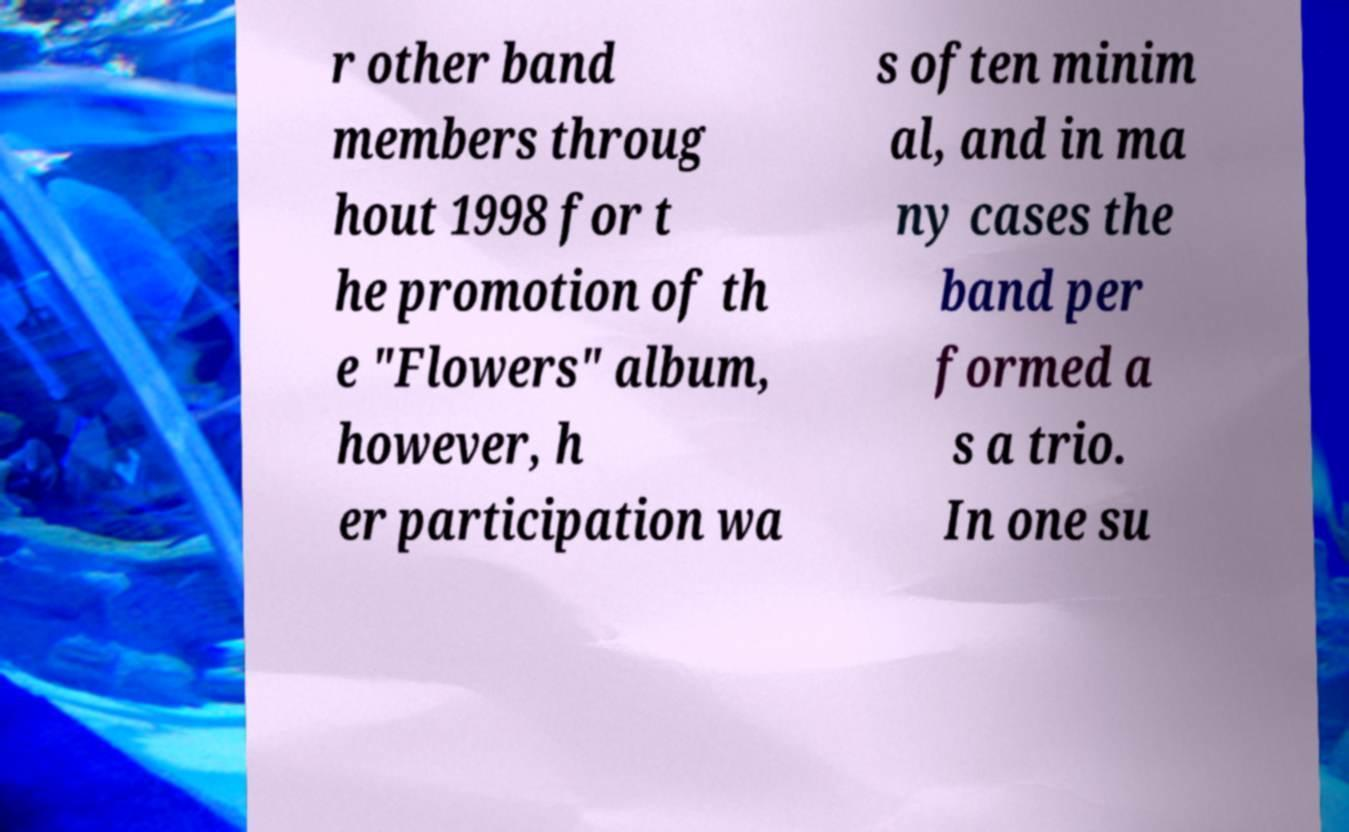Please identify and transcribe the text found in this image. r other band members throug hout 1998 for t he promotion of th e "Flowers" album, however, h er participation wa s often minim al, and in ma ny cases the band per formed a s a trio. In one su 